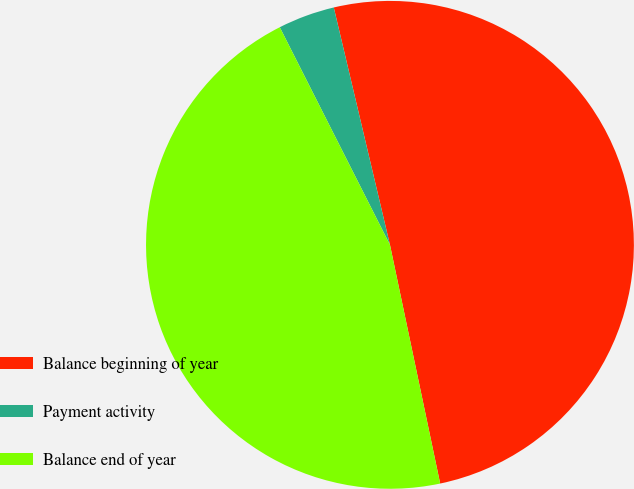Convert chart. <chart><loc_0><loc_0><loc_500><loc_500><pie_chart><fcel>Balance beginning of year<fcel>Payment activity<fcel>Balance end of year<nl><fcel>50.4%<fcel>3.76%<fcel>45.84%<nl></chart> 